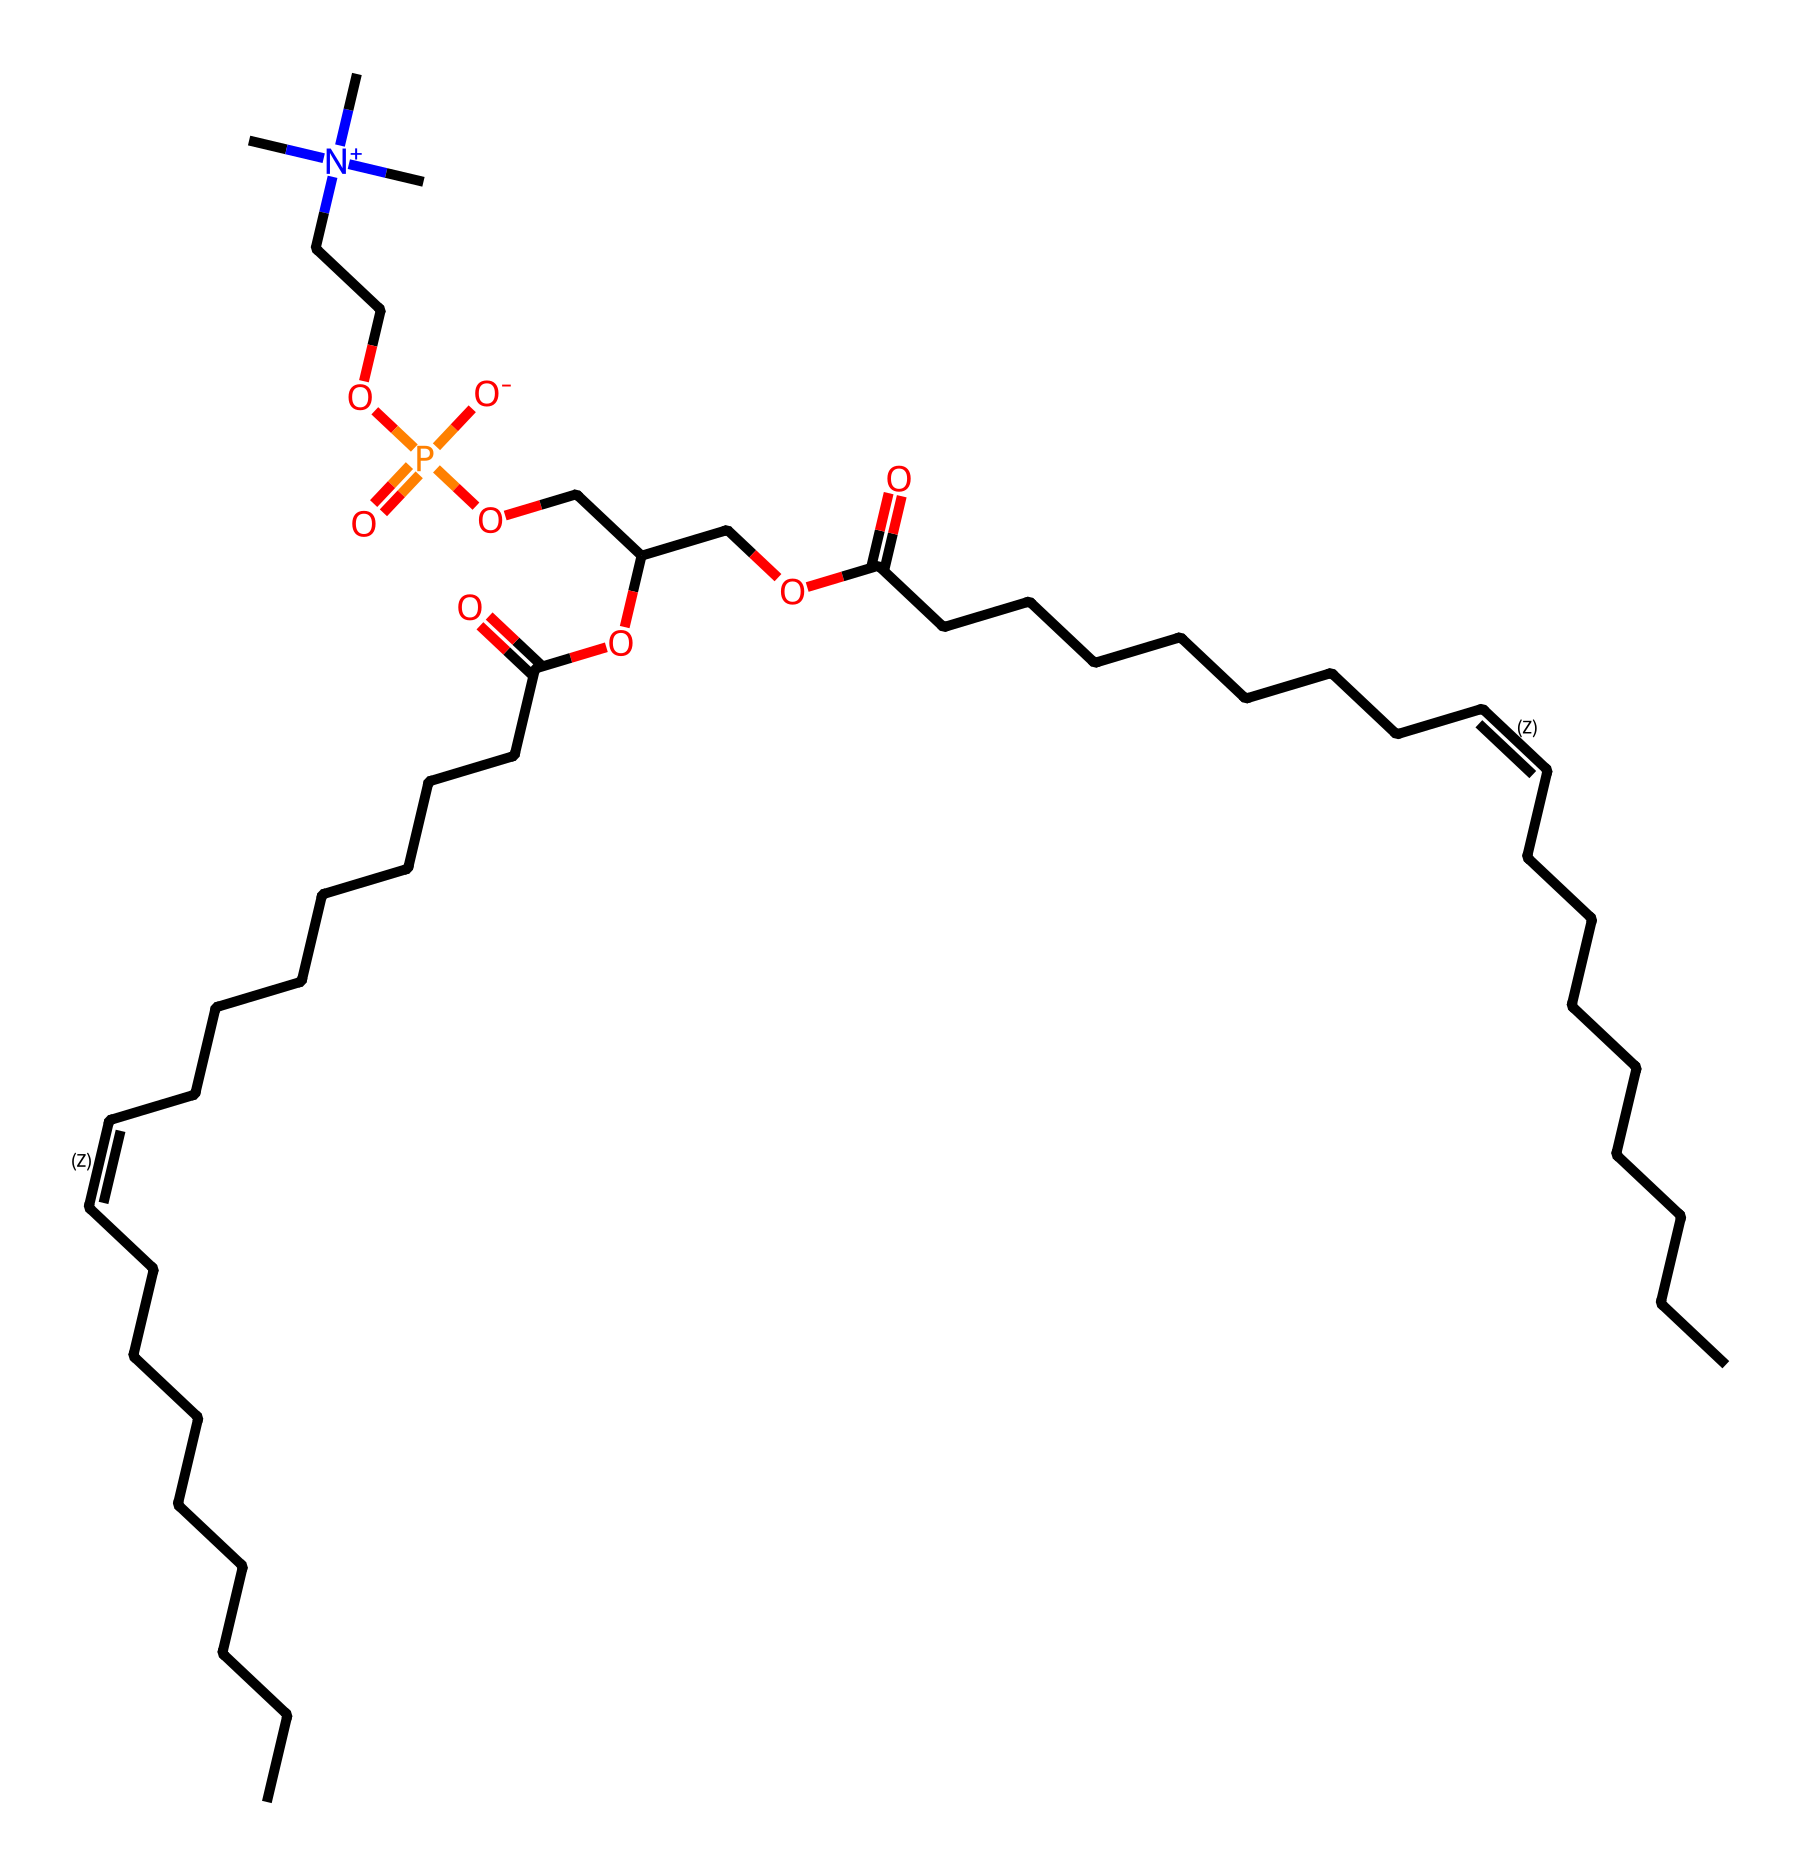What is the primary functional group present in phosphatidylcholine? The chemical structure shows a phosphate group indicated by "P(=O)([O-])O", signifying the presence of a phosphoester functional group. This group is a key characteristic of phosphatidylcholine.
Answer: phosphoester How many carbon atoms are in the tail of phosphatidylcholine? By analyzing the long hydrocarbon chains, which are denoted as "CCCCCCC/C=C\CCCCCCCC", it can be counted that there are 16 carbon atoms altogether in the two tail segments of the molecule.
Answer: sixteen What type of molecule is phosphatidylcholine classified as? Looking at the presence of both hydrophilic (phosphate group) and hydrophobic (fatty acid tails) components in the structure, phosphatidylcholine is identified as an amphipathic molecule, making it a key phospholipid.
Answer: phospholipid Are there any unsaturated bonds present in phosphatidylcholine? The "/C=C/" notation indicates that there are double bonds in the hydrocarbon chains, confirming the presence of unsaturated bonds within the structure.
Answer: yes What element is central in the phosphatidylcholine's phosphate group? The "P" in the phosphate group "P(=O)([O-])O" represents phosphorus, indicating that it is the central element in the phosphate component of phosphatidylcholine.
Answer: phosphorus How many total oxygen atoms are present in phosphatidylcholine? By counting the "O" symbols in the structural formula, including those in the phosphate group and the tails, there are four oxygen atoms in total within the molecule.
Answer: four What role does the choline component play in phosphatidylcholine? The "N+" stands for the quaternary ammonium compound choline, which is crucial for cell membrane formation and signal transduction in the body, making it significant in the function of phosphatidylcholine.
Answer: signaling 